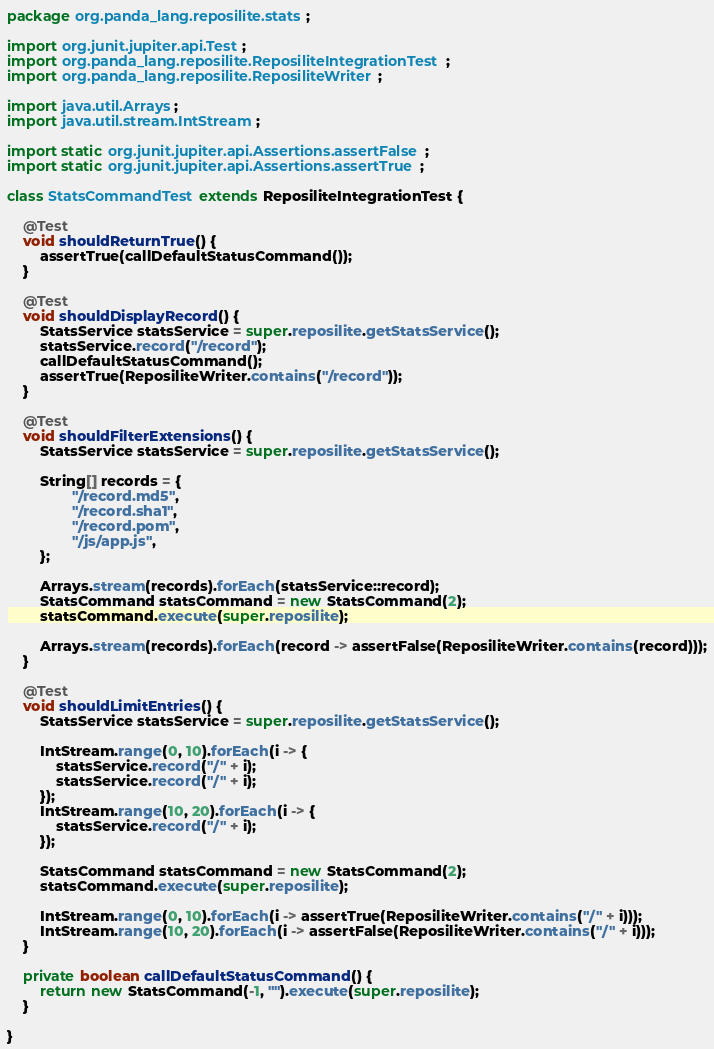<code> <loc_0><loc_0><loc_500><loc_500><_Java_>package org.panda_lang.reposilite.stats;

import org.junit.jupiter.api.Test;
import org.panda_lang.reposilite.ReposiliteIntegrationTest;
import org.panda_lang.reposilite.ReposiliteWriter;

import java.util.Arrays;
import java.util.stream.IntStream;

import static org.junit.jupiter.api.Assertions.assertFalse;
import static org.junit.jupiter.api.Assertions.assertTrue;

class StatsCommandTest extends ReposiliteIntegrationTest {

    @Test
    void shouldReturnTrue() {
        assertTrue(callDefaultStatusCommand());
    }

    @Test
    void shouldDisplayRecord() {
        StatsService statsService = super.reposilite.getStatsService();
        statsService.record("/record");
        callDefaultStatusCommand();
        assertTrue(ReposiliteWriter.contains("/record"));
    }

    @Test
    void shouldFilterExtensions() {
        StatsService statsService = super.reposilite.getStatsService();

        String[] records = {
                "/record.md5",
                "/record.sha1",
                "/record.pom",
                "/js/app.js",
        };

        Arrays.stream(records).forEach(statsService::record);
        StatsCommand statsCommand = new StatsCommand(2);
        statsCommand.execute(super.reposilite);

        Arrays.stream(records).forEach(record -> assertFalse(ReposiliteWriter.contains(record)));
    }

    @Test
    void shouldLimitEntries() {
        StatsService statsService = super.reposilite.getStatsService();

        IntStream.range(0, 10).forEach(i -> {
            statsService.record("/" + i);
            statsService.record("/" + i);
        });
        IntStream.range(10, 20).forEach(i -> {
            statsService.record("/" + i);
        });

        StatsCommand statsCommand = new StatsCommand(2);
        statsCommand.execute(super.reposilite);

        IntStream.range(0, 10).forEach(i -> assertTrue(ReposiliteWriter.contains("/" + i)));
        IntStream.range(10, 20).forEach(i -> assertFalse(ReposiliteWriter.contains("/" + i)));
    }

    private boolean callDefaultStatusCommand() {
        return new StatsCommand(-1, "").execute(super.reposilite);
    }

}</code> 